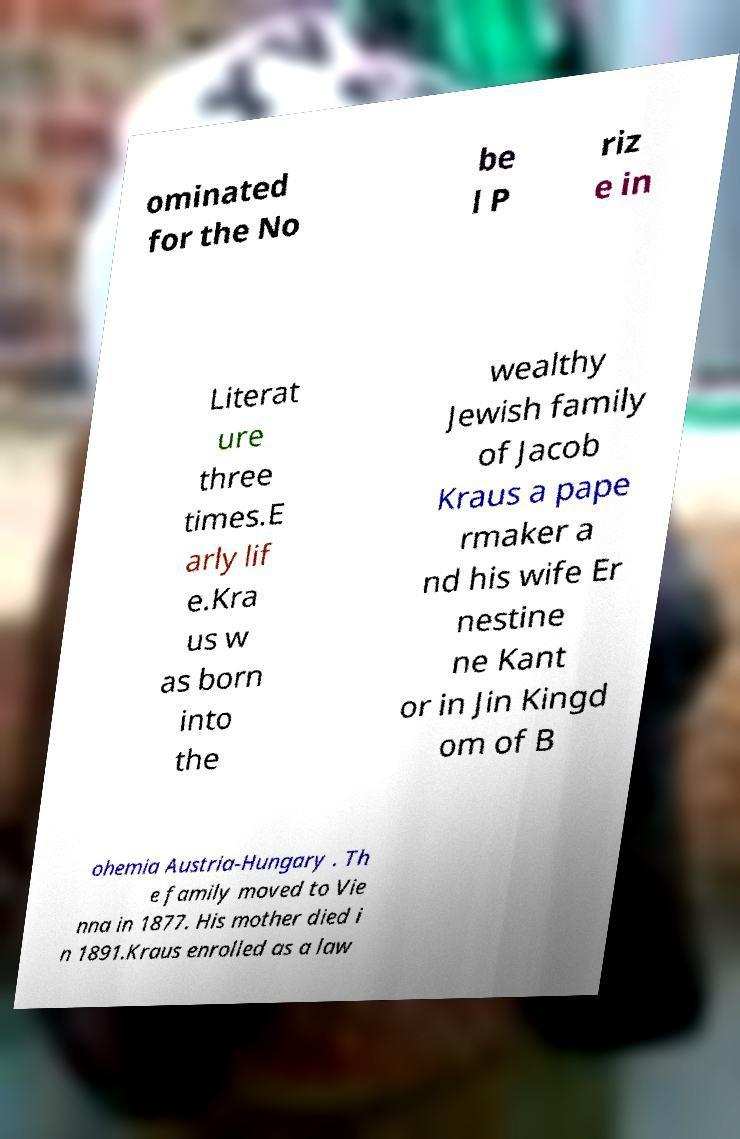What messages or text are displayed in this image? I need them in a readable, typed format. ominated for the No be l P riz e in Literat ure three times.E arly lif e.Kra us w as born into the wealthy Jewish family of Jacob Kraus a pape rmaker a nd his wife Er nestine ne Kant or in Jin Kingd om of B ohemia Austria-Hungary . Th e family moved to Vie nna in 1877. His mother died i n 1891.Kraus enrolled as a law 